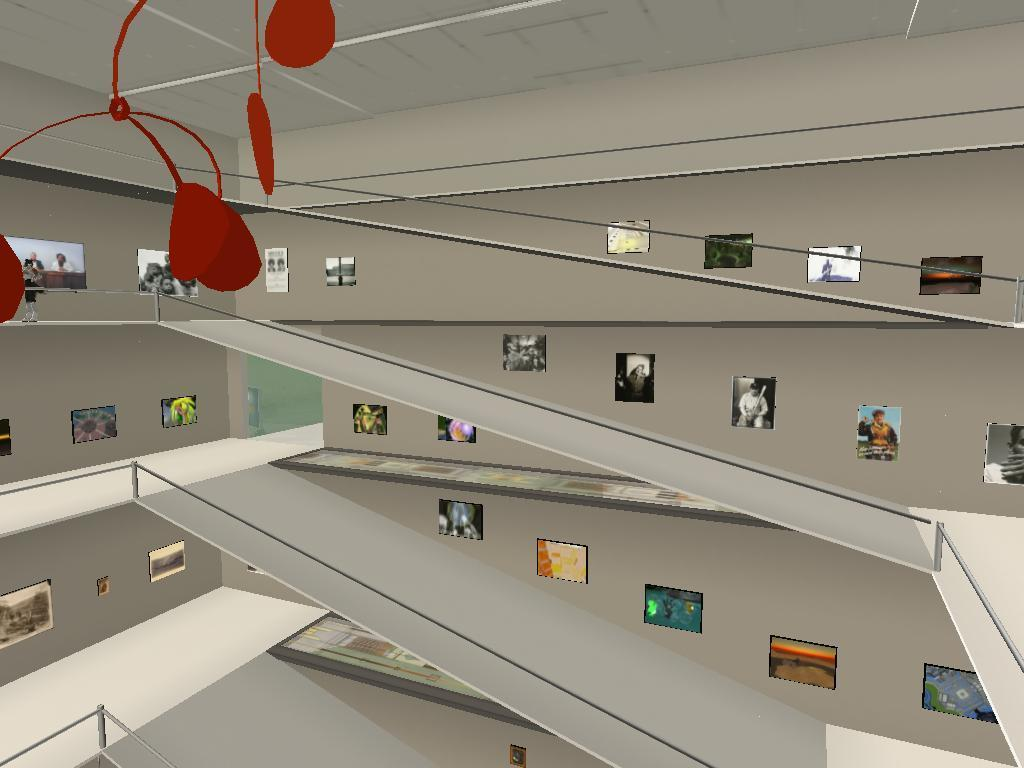What type of picture is the image? The image is an animated picture. What can be seen inside the building in the image? There is an inside view of a building in the image. What is attached to the walls in the image? There are frames attached to the walls in the image. What other objects can be seen in the image? There are other objects present in the image. What type of leaf is falling from the ceiling in the image? There is no leaf falling from the ceiling in the image; it is an animated picture of an indoor scene. 